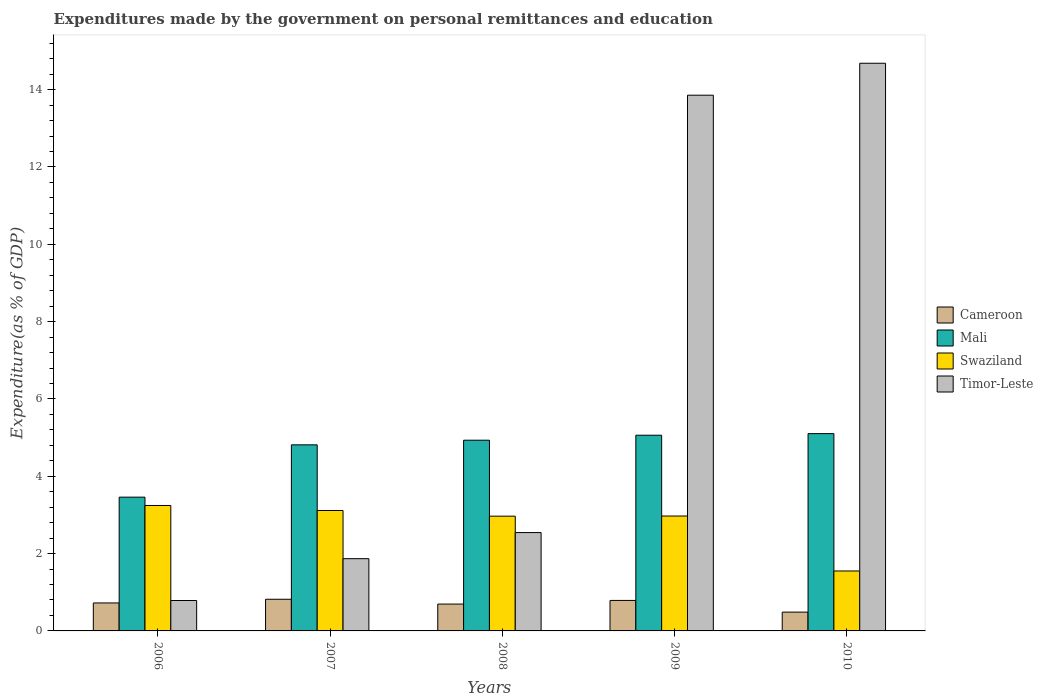How many different coloured bars are there?
Offer a very short reply. 4. How many groups of bars are there?
Provide a short and direct response. 5. Are the number of bars per tick equal to the number of legend labels?
Your answer should be compact. Yes. Are the number of bars on each tick of the X-axis equal?
Your answer should be compact. Yes. How many bars are there on the 3rd tick from the left?
Keep it short and to the point. 4. What is the label of the 3rd group of bars from the left?
Offer a very short reply. 2008. What is the expenditures made by the government on personal remittances and education in Swaziland in 2007?
Make the answer very short. 3.11. Across all years, what is the maximum expenditures made by the government on personal remittances and education in Mali?
Provide a short and direct response. 5.1. Across all years, what is the minimum expenditures made by the government on personal remittances and education in Mali?
Provide a short and direct response. 3.46. In which year was the expenditures made by the government on personal remittances and education in Timor-Leste minimum?
Ensure brevity in your answer.  2006. What is the total expenditures made by the government on personal remittances and education in Timor-Leste in the graph?
Provide a short and direct response. 33.74. What is the difference between the expenditures made by the government on personal remittances and education in Swaziland in 2007 and that in 2010?
Provide a short and direct response. 1.56. What is the difference between the expenditures made by the government on personal remittances and education in Mali in 2008 and the expenditures made by the government on personal remittances and education in Swaziland in 2010?
Provide a short and direct response. 3.38. What is the average expenditures made by the government on personal remittances and education in Swaziland per year?
Your response must be concise. 2.77. In the year 2010, what is the difference between the expenditures made by the government on personal remittances and education in Swaziland and expenditures made by the government on personal remittances and education in Mali?
Ensure brevity in your answer.  -3.55. In how many years, is the expenditures made by the government on personal remittances and education in Timor-Leste greater than 12 %?
Offer a terse response. 2. What is the ratio of the expenditures made by the government on personal remittances and education in Mali in 2006 to that in 2008?
Your answer should be very brief. 0.7. Is the expenditures made by the government on personal remittances and education in Swaziland in 2006 less than that in 2007?
Offer a very short reply. No. Is the difference between the expenditures made by the government on personal remittances and education in Swaziland in 2008 and 2010 greater than the difference between the expenditures made by the government on personal remittances and education in Mali in 2008 and 2010?
Provide a short and direct response. Yes. What is the difference between the highest and the second highest expenditures made by the government on personal remittances and education in Cameroon?
Provide a short and direct response. 0.03. What is the difference between the highest and the lowest expenditures made by the government on personal remittances and education in Swaziland?
Provide a short and direct response. 1.69. What does the 1st bar from the left in 2009 represents?
Your answer should be very brief. Cameroon. What does the 4th bar from the right in 2007 represents?
Provide a succinct answer. Cameroon. How many bars are there?
Give a very brief answer. 20. How many years are there in the graph?
Your answer should be compact. 5. What is the difference between two consecutive major ticks on the Y-axis?
Make the answer very short. 2. Does the graph contain any zero values?
Your answer should be compact. No. Does the graph contain grids?
Your response must be concise. No. Where does the legend appear in the graph?
Provide a succinct answer. Center right. How many legend labels are there?
Make the answer very short. 4. What is the title of the graph?
Offer a terse response. Expenditures made by the government on personal remittances and education. What is the label or title of the Y-axis?
Keep it short and to the point. Expenditure(as % of GDP). What is the Expenditure(as % of GDP) in Cameroon in 2006?
Make the answer very short. 0.72. What is the Expenditure(as % of GDP) of Mali in 2006?
Offer a very short reply. 3.46. What is the Expenditure(as % of GDP) in Swaziland in 2006?
Ensure brevity in your answer.  3.24. What is the Expenditure(as % of GDP) in Timor-Leste in 2006?
Your answer should be very brief. 0.79. What is the Expenditure(as % of GDP) of Cameroon in 2007?
Make the answer very short. 0.82. What is the Expenditure(as % of GDP) of Mali in 2007?
Keep it short and to the point. 4.81. What is the Expenditure(as % of GDP) of Swaziland in 2007?
Provide a short and direct response. 3.11. What is the Expenditure(as % of GDP) of Timor-Leste in 2007?
Offer a very short reply. 1.87. What is the Expenditure(as % of GDP) of Cameroon in 2008?
Your response must be concise. 0.69. What is the Expenditure(as % of GDP) in Mali in 2008?
Your response must be concise. 4.93. What is the Expenditure(as % of GDP) of Swaziland in 2008?
Give a very brief answer. 2.97. What is the Expenditure(as % of GDP) of Timor-Leste in 2008?
Give a very brief answer. 2.54. What is the Expenditure(as % of GDP) in Cameroon in 2009?
Keep it short and to the point. 0.79. What is the Expenditure(as % of GDP) of Mali in 2009?
Your answer should be compact. 5.06. What is the Expenditure(as % of GDP) in Swaziland in 2009?
Ensure brevity in your answer.  2.97. What is the Expenditure(as % of GDP) in Timor-Leste in 2009?
Offer a terse response. 13.86. What is the Expenditure(as % of GDP) of Cameroon in 2010?
Ensure brevity in your answer.  0.49. What is the Expenditure(as % of GDP) in Mali in 2010?
Ensure brevity in your answer.  5.1. What is the Expenditure(as % of GDP) of Swaziland in 2010?
Provide a short and direct response. 1.55. What is the Expenditure(as % of GDP) of Timor-Leste in 2010?
Make the answer very short. 14.68. Across all years, what is the maximum Expenditure(as % of GDP) of Cameroon?
Provide a short and direct response. 0.82. Across all years, what is the maximum Expenditure(as % of GDP) of Mali?
Keep it short and to the point. 5.1. Across all years, what is the maximum Expenditure(as % of GDP) of Swaziland?
Make the answer very short. 3.24. Across all years, what is the maximum Expenditure(as % of GDP) of Timor-Leste?
Your answer should be compact. 14.68. Across all years, what is the minimum Expenditure(as % of GDP) in Cameroon?
Provide a short and direct response. 0.49. Across all years, what is the minimum Expenditure(as % of GDP) in Mali?
Offer a very short reply. 3.46. Across all years, what is the minimum Expenditure(as % of GDP) in Swaziland?
Your answer should be compact. 1.55. Across all years, what is the minimum Expenditure(as % of GDP) of Timor-Leste?
Offer a very short reply. 0.79. What is the total Expenditure(as % of GDP) of Cameroon in the graph?
Ensure brevity in your answer.  3.51. What is the total Expenditure(as % of GDP) of Mali in the graph?
Offer a terse response. 23.37. What is the total Expenditure(as % of GDP) in Swaziland in the graph?
Ensure brevity in your answer.  13.85. What is the total Expenditure(as % of GDP) in Timor-Leste in the graph?
Your response must be concise. 33.74. What is the difference between the Expenditure(as % of GDP) in Cameroon in 2006 and that in 2007?
Keep it short and to the point. -0.1. What is the difference between the Expenditure(as % of GDP) in Mali in 2006 and that in 2007?
Your answer should be compact. -1.35. What is the difference between the Expenditure(as % of GDP) in Swaziland in 2006 and that in 2007?
Offer a very short reply. 0.13. What is the difference between the Expenditure(as % of GDP) in Timor-Leste in 2006 and that in 2007?
Make the answer very short. -1.08. What is the difference between the Expenditure(as % of GDP) of Cameroon in 2006 and that in 2008?
Provide a succinct answer. 0.03. What is the difference between the Expenditure(as % of GDP) of Mali in 2006 and that in 2008?
Provide a short and direct response. -1.47. What is the difference between the Expenditure(as % of GDP) of Swaziland in 2006 and that in 2008?
Make the answer very short. 0.28. What is the difference between the Expenditure(as % of GDP) of Timor-Leste in 2006 and that in 2008?
Give a very brief answer. -1.76. What is the difference between the Expenditure(as % of GDP) in Cameroon in 2006 and that in 2009?
Your answer should be compact. -0.06. What is the difference between the Expenditure(as % of GDP) of Mali in 2006 and that in 2009?
Your response must be concise. -1.6. What is the difference between the Expenditure(as % of GDP) in Swaziland in 2006 and that in 2009?
Your answer should be compact. 0.27. What is the difference between the Expenditure(as % of GDP) of Timor-Leste in 2006 and that in 2009?
Your response must be concise. -13.07. What is the difference between the Expenditure(as % of GDP) of Cameroon in 2006 and that in 2010?
Offer a very short reply. 0.24. What is the difference between the Expenditure(as % of GDP) of Mali in 2006 and that in 2010?
Your answer should be compact. -1.64. What is the difference between the Expenditure(as % of GDP) of Swaziland in 2006 and that in 2010?
Give a very brief answer. 1.69. What is the difference between the Expenditure(as % of GDP) of Timor-Leste in 2006 and that in 2010?
Keep it short and to the point. -13.9. What is the difference between the Expenditure(as % of GDP) in Cameroon in 2007 and that in 2008?
Your answer should be very brief. 0.12. What is the difference between the Expenditure(as % of GDP) in Mali in 2007 and that in 2008?
Make the answer very short. -0.12. What is the difference between the Expenditure(as % of GDP) in Swaziland in 2007 and that in 2008?
Provide a succinct answer. 0.15. What is the difference between the Expenditure(as % of GDP) of Timor-Leste in 2007 and that in 2008?
Your answer should be very brief. -0.68. What is the difference between the Expenditure(as % of GDP) of Cameroon in 2007 and that in 2009?
Ensure brevity in your answer.  0.03. What is the difference between the Expenditure(as % of GDP) of Mali in 2007 and that in 2009?
Offer a terse response. -0.25. What is the difference between the Expenditure(as % of GDP) in Swaziland in 2007 and that in 2009?
Your answer should be very brief. 0.14. What is the difference between the Expenditure(as % of GDP) of Timor-Leste in 2007 and that in 2009?
Ensure brevity in your answer.  -11.99. What is the difference between the Expenditure(as % of GDP) in Cameroon in 2007 and that in 2010?
Offer a terse response. 0.33. What is the difference between the Expenditure(as % of GDP) of Mali in 2007 and that in 2010?
Ensure brevity in your answer.  -0.29. What is the difference between the Expenditure(as % of GDP) of Swaziland in 2007 and that in 2010?
Offer a very short reply. 1.56. What is the difference between the Expenditure(as % of GDP) of Timor-Leste in 2007 and that in 2010?
Ensure brevity in your answer.  -12.81. What is the difference between the Expenditure(as % of GDP) in Cameroon in 2008 and that in 2009?
Make the answer very short. -0.09. What is the difference between the Expenditure(as % of GDP) in Mali in 2008 and that in 2009?
Offer a terse response. -0.13. What is the difference between the Expenditure(as % of GDP) in Swaziland in 2008 and that in 2009?
Your response must be concise. -0. What is the difference between the Expenditure(as % of GDP) in Timor-Leste in 2008 and that in 2009?
Your answer should be very brief. -11.31. What is the difference between the Expenditure(as % of GDP) in Cameroon in 2008 and that in 2010?
Your response must be concise. 0.21. What is the difference between the Expenditure(as % of GDP) of Mali in 2008 and that in 2010?
Your response must be concise. -0.17. What is the difference between the Expenditure(as % of GDP) of Swaziland in 2008 and that in 2010?
Your response must be concise. 1.42. What is the difference between the Expenditure(as % of GDP) of Timor-Leste in 2008 and that in 2010?
Offer a very short reply. -12.14. What is the difference between the Expenditure(as % of GDP) of Cameroon in 2009 and that in 2010?
Your answer should be compact. 0.3. What is the difference between the Expenditure(as % of GDP) in Mali in 2009 and that in 2010?
Keep it short and to the point. -0.04. What is the difference between the Expenditure(as % of GDP) of Swaziland in 2009 and that in 2010?
Your response must be concise. 1.42. What is the difference between the Expenditure(as % of GDP) of Timor-Leste in 2009 and that in 2010?
Provide a succinct answer. -0.83. What is the difference between the Expenditure(as % of GDP) of Cameroon in 2006 and the Expenditure(as % of GDP) of Mali in 2007?
Provide a short and direct response. -4.09. What is the difference between the Expenditure(as % of GDP) of Cameroon in 2006 and the Expenditure(as % of GDP) of Swaziland in 2007?
Ensure brevity in your answer.  -2.39. What is the difference between the Expenditure(as % of GDP) of Cameroon in 2006 and the Expenditure(as % of GDP) of Timor-Leste in 2007?
Keep it short and to the point. -1.14. What is the difference between the Expenditure(as % of GDP) of Mali in 2006 and the Expenditure(as % of GDP) of Swaziland in 2007?
Make the answer very short. 0.35. What is the difference between the Expenditure(as % of GDP) of Mali in 2006 and the Expenditure(as % of GDP) of Timor-Leste in 2007?
Ensure brevity in your answer.  1.59. What is the difference between the Expenditure(as % of GDP) of Swaziland in 2006 and the Expenditure(as % of GDP) of Timor-Leste in 2007?
Ensure brevity in your answer.  1.38. What is the difference between the Expenditure(as % of GDP) in Cameroon in 2006 and the Expenditure(as % of GDP) in Mali in 2008?
Make the answer very short. -4.21. What is the difference between the Expenditure(as % of GDP) in Cameroon in 2006 and the Expenditure(as % of GDP) in Swaziland in 2008?
Ensure brevity in your answer.  -2.24. What is the difference between the Expenditure(as % of GDP) in Cameroon in 2006 and the Expenditure(as % of GDP) in Timor-Leste in 2008?
Your response must be concise. -1.82. What is the difference between the Expenditure(as % of GDP) of Mali in 2006 and the Expenditure(as % of GDP) of Swaziland in 2008?
Make the answer very short. 0.49. What is the difference between the Expenditure(as % of GDP) in Mali in 2006 and the Expenditure(as % of GDP) in Timor-Leste in 2008?
Ensure brevity in your answer.  0.92. What is the difference between the Expenditure(as % of GDP) of Swaziland in 2006 and the Expenditure(as % of GDP) of Timor-Leste in 2008?
Your answer should be compact. 0.7. What is the difference between the Expenditure(as % of GDP) in Cameroon in 2006 and the Expenditure(as % of GDP) in Mali in 2009?
Your response must be concise. -4.34. What is the difference between the Expenditure(as % of GDP) of Cameroon in 2006 and the Expenditure(as % of GDP) of Swaziland in 2009?
Provide a short and direct response. -2.25. What is the difference between the Expenditure(as % of GDP) of Cameroon in 2006 and the Expenditure(as % of GDP) of Timor-Leste in 2009?
Provide a succinct answer. -13.13. What is the difference between the Expenditure(as % of GDP) of Mali in 2006 and the Expenditure(as % of GDP) of Swaziland in 2009?
Keep it short and to the point. 0.49. What is the difference between the Expenditure(as % of GDP) of Mali in 2006 and the Expenditure(as % of GDP) of Timor-Leste in 2009?
Your answer should be very brief. -10.4. What is the difference between the Expenditure(as % of GDP) of Swaziland in 2006 and the Expenditure(as % of GDP) of Timor-Leste in 2009?
Offer a very short reply. -10.61. What is the difference between the Expenditure(as % of GDP) of Cameroon in 2006 and the Expenditure(as % of GDP) of Mali in 2010?
Offer a very short reply. -4.38. What is the difference between the Expenditure(as % of GDP) of Cameroon in 2006 and the Expenditure(as % of GDP) of Swaziland in 2010?
Give a very brief answer. -0.83. What is the difference between the Expenditure(as % of GDP) of Cameroon in 2006 and the Expenditure(as % of GDP) of Timor-Leste in 2010?
Ensure brevity in your answer.  -13.96. What is the difference between the Expenditure(as % of GDP) of Mali in 2006 and the Expenditure(as % of GDP) of Swaziland in 2010?
Your answer should be very brief. 1.91. What is the difference between the Expenditure(as % of GDP) of Mali in 2006 and the Expenditure(as % of GDP) of Timor-Leste in 2010?
Provide a short and direct response. -11.22. What is the difference between the Expenditure(as % of GDP) in Swaziland in 2006 and the Expenditure(as % of GDP) in Timor-Leste in 2010?
Your answer should be compact. -11.44. What is the difference between the Expenditure(as % of GDP) in Cameroon in 2007 and the Expenditure(as % of GDP) in Mali in 2008?
Your response must be concise. -4.11. What is the difference between the Expenditure(as % of GDP) in Cameroon in 2007 and the Expenditure(as % of GDP) in Swaziland in 2008?
Make the answer very short. -2.15. What is the difference between the Expenditure(as % of GDP) in Cameroon in 2007 and the Expenditure(as % of GDP) in Timor-Leste in 2008?
Your response must be concise. -1.73. What is the difference between the Expenditure(as % of GDP) in Mali in 2007 and the Expenditure(as % of GDP) in Swaziland in 2008?
Ensure brevity in your answer.  1.84. What is the difference between the Expenditure(as % of GDP) of Mali in 2007 and the Expenditure(as % of GDP) of Timor-Leste in 2008?
Your response must be concise. 2.27. What is the difference between the Expenditure(as % of GDP) in Swaziland in 2007 and the Expenditure(as % of GDP) in Timor-Leste in 2008?
Keep it short and to the point. 0.57. What is the difference between the Expenditure(as % of GDP) in Cameroon in 2007 and the Expenditure(as % of GDP) in Mali in 2009?
Your answer should be compact. -4.24. What is the difference between the Expenditure(as % of GDP) in Cameroon in 2007 and the Expenditure(as % of GDP) in Swaziland in 2009?
Keep it short and to the point. -2.15. What is the difference between the Expenditure(as % of GDP) in Cameroon in 2007 and the Expenditure(as % of GDP) in Timor-Leste in 2009?
Make the answer very short. -13.04. What is the difference between the Expenditure(as % of GDP) of Mali in 2007 and the Expenditure(as % of GDP) of Swaziland in 2009?
Provide a succinct answer. 1.84. What is the difference between the Expenditure(as % of GDP) of Mali in 2007 and the Expenditure(as % of GDP) of Timor-Leste in 2009?
Give a very brief answer. -9.04. What is the difference between the Expenditure(as % of GDP) of Swaziland in 2007 and the Expenditure(as % of GDP) of Timor-Leste in 2009?
Make the answer very short. -10.74. What is the difference between the Expenditure(as % of GDP) in Cameroon in 2007 and the Expenditure(as % of GDP) in Mali in 2010?
Give a very brief answer. -4.28. What is the difference between the Expenditure(as % of GDP) in Cameroon in 2007 and the Expenditure(as % of GDP) in Swaziland in 2010?
Give a very brief answer. -0.73. What is the difference between the Expenditure(as % of GDP) in Cameroon in 2007 and the Expenditure(as % of GDP) in Timor-Leste in 2010?
Offer a very short reply. -13.86. What is the difference between the Expenditure(as % of GDP) of Mali in 2007 and the Expenditure(as % of GDP) of Swaziland in 2010?
Ensure brevity in your answer.  3.26. What is the difference between the Expenditure(as % of GDP) in Mali in 2007 and the Expenditure(as % of GDP) in Timor-Leste in 2010?
Make the answer very short. -9.87. What is the difference between the Expenditure(as % of GDP) in Swaziland in 2007 and the Expenditure(as % of GDP) in Timor-Leste in 2010?
Ensure brevity in your answer.  -11.57. What is the difference between the Expenditure(as % of GDP) in Cameroon in 2008 and the Expenditure(as % of GDP) in Mali in 2009?
Give a very brief answer. -4.37. What is the difference between the Expenditure(as % of GDP) in Cameroon in 2008 and the Expenditure(as % of GDP) in Swaziland in 2009?
Ensure brevity in your answer.  -2.28. What is the difference between the Expenditure(as % of GDP) in Cameroon in 2008 and the Expenditure(as % of GDP) in Timor-Leste in 2009?
Offer a very short reply. -13.16. What is the difference between the Expenditure(as % of GDP) of Mali in 2008 and the Expenditure(as % of GDP) of Swaziland in 2009?
Ensure brevity in your answer.  1.96. What is the difference between the Expenditure(as % of GDP) in Mali in 2008 and the Expenditure(as % of GDP) in Timor-Leste in 2009?
Your response must be concise. -8.92. What is the difference between the Expenditure(as % of GDP) of Swaziland in 2008 and the Expenditure(as % of GDP) of Timor-Leste in 2009?
Offer a very short reply. -10.89. What is the difference between the Expenditure(as % of GDP) of Cameroon in 2008 and the Expenditure(as % of GDP) of Mali in 2010?
Keep it short and to the point. -4.41. What is the difference between the Expenditure(as % of GDP) in Cameroon in 2008 and the Expenditure(as % of GDP) in Swaziland in 2010?
Ensure brevity in your answer.  -0.86. What is the difference between the Expenditure(as % of GDP) in Cameroon in 2008 and the Expenditure(as % of GDP) in Timor-Leste in 2010?
Your answer should be compact. -13.99. What is the difference between the Expenditure(as % of GDP) of Mali in 2008 and the Expenditure(as % of GDP) of Swaziland in 2010?
Provide a succinct answer. 3.38. What is the difference between the Expenditure(as % of GDP) in Mali in 2008 and the Expenditure(as % of GDP) in Timor-Leste in 2010?
Make the answer very short. -9.75. What is the difference between the Expenditure(as % of GDP) in Swaziland in 2008 and the Expenditure(as % of GDP) in Timor-Leste in 2010?
Give a very brief answer. -11.71. What is the difference between the Expenditure(as % of GDP) in Cameroon in 2009 and the Expenditure(as % of GDP) in Mali in 2010?
Offer a very short reply. -4.31. What is the difference between the Expenditure(as % of GDP) of Cameroon in 2009 and the Expenditure(as % of GDP) of Swaziland in 2010?
Ensure brevity in your answer.  -0.76. What is the difference between the Expenditure(as % of GDP) of Cameroon in 2009 and the Expenditure(as % of GDP) of Timor-Leste in 2010?
Make the answer very short. -13.89. What is the difference between the Expenditure(as % of GDP) in Mali in 2009 and the Expenditure(as % of GDP) in Swaziland in 2010?
Offer a terse response. 3.51. What is the difference between the Expenditure(as % of GDP) of Mali in 2009 and the Expenditure(as % of GDP) of Timor-Leste in 2010?
Your response must be concise. -9.62. What is the difference between the Expenditure(as % of GDP) in Swaziland in 2009 and the Expenditure(as % of GDP) in Timor-Leste in 2010?
Keep it short and to the point. -11.71. What is the average Expenditure(as % of GDP) in Cameroon per year?
Provide a short and direct response. 0.7. What is the average Expenditure(as % of GDP) of Mali per year?
Ensure brevity in your answer.  4.67. What is the average Expenditure(as % of GDP) in Swaziland per year?
Offer a terse response. 2.77. What is the average Expenditure(as % of GDP) in Timor-Leste per year?
Your response must be concise. 6.75. In the year 2006, what is the difference between the Expenditure(as % of GDP) of Cameroon and Expenditure(as % of GDP) of Mali?
Your answer should be very brief. -2.74. In the year 2006, what is the difference between the Expenditure(as % of GDP) of Cameroon and Expenditure(as % of GDP) of Swaziland?
Your response must be concise. -2.52. In the year 2006, what is the difference between the Expenditure(as % of GDP) in Cameroon and Expenditure(as % of GDP) in Timor-Leste?
Provide a succinct answer. -0.06. In the year 2006, what is the difference between the Expenditure(as % of GDP) in Mali and Expenditure(as % of GDP) in Swaziland?
Ensure brevity in your answer.  0.22. In the year 2006, what is the difference between the Expenditure(as % of GDP) in Mali and Expenditure(as % of GDP) in Timor-Leste?
Give a very brief answer. 2.67. In the year 2006, what is the difference between the Expenditure(as % of GDP) in Swaziland and Expenditure(as % of GDP) in Timor-Leste?
Your answer should be compact. 2.46. In the year 2007, what is the difference between the Expenditure(as % of GDP) in Cameroon and Expenditure(as % of GDP) in Mali?
Your response must be concise. -3.99. In the year 2007, what is the difference between the Expenditure(as % of GDP) in Cameroon and Expenditure(as % of GDP) in Swaziland?
Make the answer very short. -2.3. In the year 2007, what is the difference between the Expenditure(as % of GDP) of Cameroon and Expenditure(as % of GDP) of Timor-Leste?
Give a very brief answer. -1.05. In the year 2007, what is the difference between the Expenditure(as % of GDP) of Mali and Expenditure(as % of GDP) of Swaziland?
Keep it short and to the point. 1.7. In the year 2007, what is the difference between the Expenditure(as % of GDP) in Mali and Expenditure(as % of GDP) in Timor-Leste?
Provide a succinct answer. 2.94. In the year 2007, what is the difference between the Expenditure(as % of GDP) of Swaziland and Expenditure(as % of GDP) of Timor-Leste?
Provide a succinct answer. 1.25. In the year 2008, what is the difference between the Expenditure(as % of GDP) in Cameroon and Expenditure(as % of GDP) in Mali?
Give a very brief answer. -4.24. In the year 2008, what is the difference between the Expenditure(as % of GDP) of Cameroon and Expenditure(as % of GDP) of Swaziland?
Provide a succinct answer. -2.27. In the year 2008, what is the difference between the Expenditure(as % of GDP) of Cameroon and Expenditure(as % of GDP) of Timor-Leste?
Offer a very short reply. -1.85. In the year 2008, what is the difference between the Expenditure(as % of GDP) of Mali and Expenditure(as % of GDP) of Swaziland?
Your answer should be compact. 1.96. In the year 2008, what is the difference between the Expenditure(as % of GDP) in Mali and Expenditure(as % of GDP) in Timor-Leste?
Offer a terse response. 2.39. In the year 2008, what is the difference between the Expenditure(as % of GDP) of Swaziland and Expenditure(as % of GDP) of Timor-Leste?
Your answer should be compact. 0.42. In the year 2009, what is the difference between the Expenditure(as % of GDP) in Cameroon and Expenditure(as % of GDP) in Mali?
Provide a short and direct response. -4.27. In the year 2009, what is the difference between the Expenditure(as % of GDP) in Cameroon and Expenditure(as % of GDP) in Swaziland?
Your answer should be very brief. -2.18. In the year 2009, what is the difference between the Expenditure(as % of GDP) of Cameroon and Expenditure(as % of GDP) of Timor-Leste?
Your response must be concise. -13.07. In the year 2009, what is the difference between the Expenditure(as % of GDP) in Mali and Expenditure(as % of GDP) in Swaziland?
Provide a short and direct response. 2.09. In the year 2009, what is the difference between the Expenditure(as % of GDP) of Mali and Expenditure(as % of GDP) of Timor-Leste?
Offer a terse response. -8.8. In the year 2009, what is the difference between the Expenditure(as % of GDP) of Swaziland and Expenditure(as % of GDP) of Timor-Leste?
Give a very brief answer. -10.88. In the year 2010, what is the difference between the Expenditure(as % of GDP) of Cameroon and Expenditure(as % of GDP) of Mali?
Provide a short and direct response. -4.62. In the year 2010, what is the difference between the Expenditure(as % of GDP) of Cameroon and Expenditure(as % of GDP) of Swaziland?
Your response must be concise. -1.06. In the year 2010, what is the difference between the Expenditure(as % of GDP) in Cameroon and Expenditure(as % of GDP) in Timor-Leste?
Your answer should be very brief. -14.2. In the year 2010, what is the difference between the Expenditure(as % of GDP) in Mali and Expenditure(as % of GDP) in Swaziland?
Give a very brief answer. 3.55. In the year 2010, what is the difference between the Expenditure(as % of GDP) in Mali and Expenditure(as % of GDP) in Timor-Leste?
Give a very brief answer. -9.58. In the year 2010, what is the difference between the Expenditure(as % of GDP) in Swaziland and Expenditure(as % of GDP) in Timor-Leste?
Your answer should be compact. -13.13. What is the ratio of the Expenditure(as % of GDP) in Cameroon in 2006 to that in 2007?
Ensure brevity in your answer.  0.88. What is the ratio of the Expenditure(as % of GDP) in Mali in 2006 to that in 2007?
Offer a terse response. 0.72. What is the ratio of the Expenditure(as % of GDP) of Swaziland in 2006 to that in 2007?
Your answer should be very brief. 1.04. What is the ratio of the Expenditure(as % of GDP) in Timor-Leste in 2006 to that in 2007?
Your response must be concise. 0.42. What is the ratio of the Expenditure(as % of GDP) in Cameroon in 2006 to that in 2008?
Offer a very short reply. 1.04. What is the ratio of the Expenditure(as % of GDP) of Mali in 2006 to that in 2008?
Make the answer very short. 0.7. What is the ratio of the Expenditure(as % of GDP) of Swaziland in 2006 to that in 2008?
Give a very brief answer. 1.09. What is the ratio of the Expenditure(as % of GDP) of Timor-Leste in 2006 to that in 2008?
Provide a succinct answer. 0.31. What is the ratio of the Expenditure(as % of GDP) of Cameroon in 2006 to that in 2009?
Provide a succinct answer. 0.92. What is the ratio of the Expenditure(as % of GDP) of Mali in 2006 to that in 2009?
Offer a terse response. 0.68. What is the ratio of the Expenditure(as % of GDP) of Swaziland in 2006 to that in 2009?
Provide a succinct answer. 1.09. What is the ratio of the Expenditure(as % of GDP) of Timor-Leste in 2006 to that in 2009?
Your answer should be very brief. 0.06. What is the ratio of the Expenditure(as % of GDP) in Cameroon in 2006 to that in 2010?
Offer a very short reply. 1.49. What is the ratio of the Expenditure(as % of GDP) of Mali in 2006 to that in 2010?
Your response must be concise. 0.68. What is the ratio of the Expenditure(as % of GDP) in Swaziland in 2006 to that in 2010?
Offer a very short reply. 2.09. What is the ratio of the Expenditure(as % of GDP) of Timor-Leste in 2006 to that in 2010?
Make the answer very short. 0.05. What is the ratio of the Expenditure(as % of GDP) in Cameroon in 2007 to that in 2008?
Your answer should be very brief. 1.18. What is the ratio of the Expenditure(as % of GDP) in Mali in 2007 to that in 2008?
Keep it short and to the point. 0.98. What is the ratio of the Expenditure(as % of GDP) of Swaziland in 2007 to that in 2008?
Your answer should be compact. 1.05. What is the ratio of the Expenditure(as % of GDP) in Timor-Leste in 2007 to that in 2008?
Offer a very short reply. 0.73. What is the ratio of the Expenditure(as % of GDP) of Cameroon in 2007 to that in 2009?
Keep it short and to the point. 1.04. What is the ratio of the Expenditure(as % of GDP) of Mali in 2007 to that in 2009?
Ensure brevity in your answer.  0.95. What is the ratio of the Expenditure(as % of GDP) of Swaziland in 2007 to that in 2009?
Your answer should be very brief. 1.05. What is the ratio of the Expenditure(as % of GDP) in Timor-Leste in 2007 to that in 2009?
Offer a terse response. 0.13. What is the ratio of the Expenditure(as % of GDP) of Cameroon in 2007 to that in 2010?
Offer a terse response. 1.68. What is the ratio of the Expenditure(as % of GDP) in Mali in 2007 to that in 2010?
Offer a terse response. 0.94. What is the ratio of the Expenditure(as % of GDP) in Swaziland in 2007 to that in 2010?
Offer a very short reply. 2.01. What is the ratio of the Expenditure(as % of GDP) in Timor-Leste in 2007 to that in 2010?
Make the answer very short. 0.13. What is the ratio of the Expenditure(as % of GDP) of Cameroon in 2008 to that in 2009?
Make the answer very short. 0.88. What is the ratio of the Expenditure(as % of GDP) in Mali in 2008 to that in 2009?
Provide a succinct answer. 0.97. What is the ratio of the Expenditure(as % of GDP) in Swaziland in 2008 to that in 2009?
Give a very brief answer. 1. What is the ratio of the Expenditure(as % of GDP) of Timor-Leste in 2008 to that in 2009?
Provide a succinct answer. 0.18. What is the ratio of the Expenditure(as % of GDP) of Cameroon in 2008 to that in 2010?
Keep it short and to the point. 1.43. What is the ratio of the Expenditure(as % of GDP) in Mali in 2008 to that in 2010?
Your answer should be compact. 0.97. What is the ratio of the Expenditure(as % of GDP) in Swaziland in 2008 to that in 2010?
Ensure brevity in your answer.  1.91. What is the ratio of the Expenditure(as % of GDP) in Timor-Leste in 2008 to that in 2010?
Your answer should be compact. 0.17. What is the ratio of the Expenditure(as % of GDP) of Cameroon in 2009 to that in 2010?
Keep it short and to the point. 1.62. What is the ratio of the Expenditure(as % of GDP) in Swaziland in 2009 to that in 2010?
Make the answer very short. 1.92. What is the ratio of the Expenditure(as % of GDP) of Timor-Leste in 2009 to that in 2010?
Provide a succinct answer. 0.94. What is the difference between the highest and the second highest Expenditure(as % of GDP) of Cameroon?
Keep it short and to the point. 0.03. What is the difference between the highest and the second highest Expenditure(as % of GDP) of Mali?
Provide a short and direct response. 0.04. What is the difference between the highest and the second highest Expenditure(as % of GDP) in Swaziland?
Your response must be concise. 0.13. What is the difference between the highest and the second highest Expenditure(as % of GDP) of Timor-Leste?
Provide a succinct answer. 0.83. What is the difference between the highest and the lowest Expenditure(as % of GDP) of Cameroon?
Provide a short and direct response. 0.33. What is the difference between the highest and the lowest Expenditure(as % of GDP) in Mali?
Your answer should be very brief. 1.64. What is the difference between the highest and the lowest Expenditure(as % of GDP) in Swaziland?
Provide a succinct answer. 1.69. What is the difference between the highest and the lowest Expenditure(as % of GDP) of Timor-Leste?
Provide a succinct answer. 13.9. 